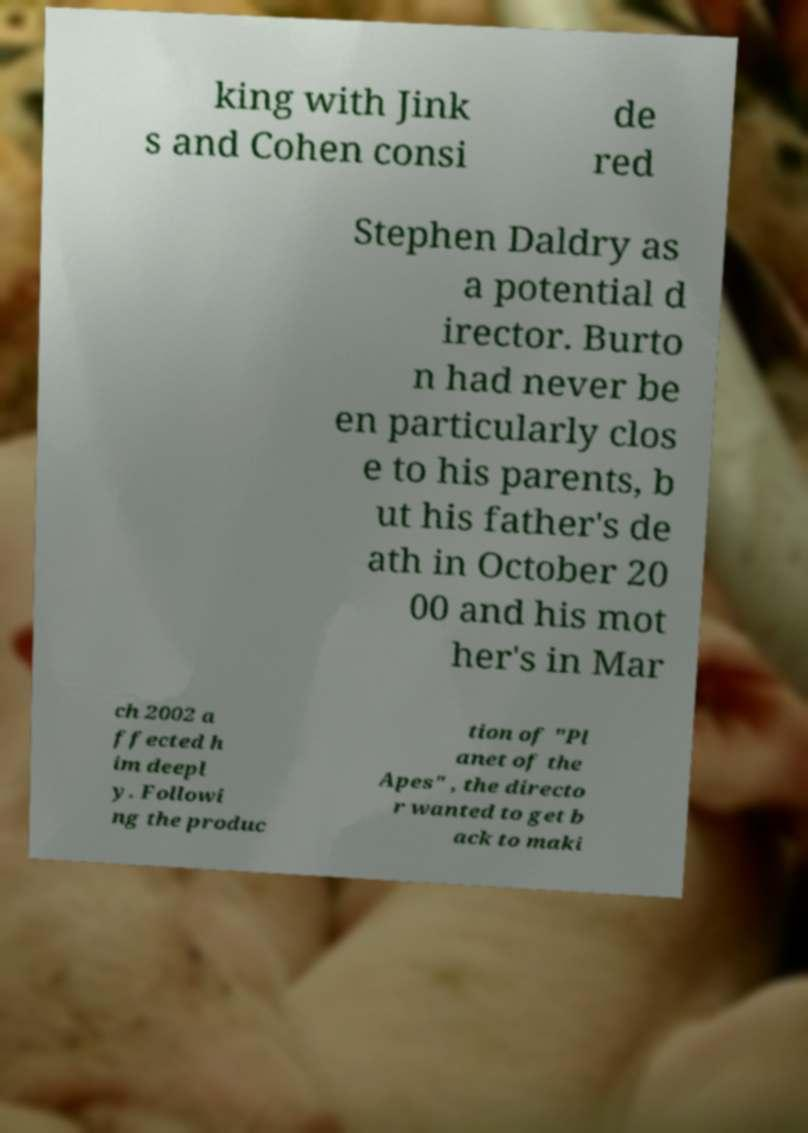There's text embedded in this image that I need extracted. Can you transcribe it verbatim? king with Jink s and Cohen consi de red Stephen Daldry as a potential d irector. Burto n had never be en particularly clos e to his parents, b ut his father's de ath in October 20 00 and his mot her's in Mar ch 2002 a ffected h im deepl y. Followi ng the produc tion of "Pl anet of the Apes" , the directo r wanted to get b ack to maki 